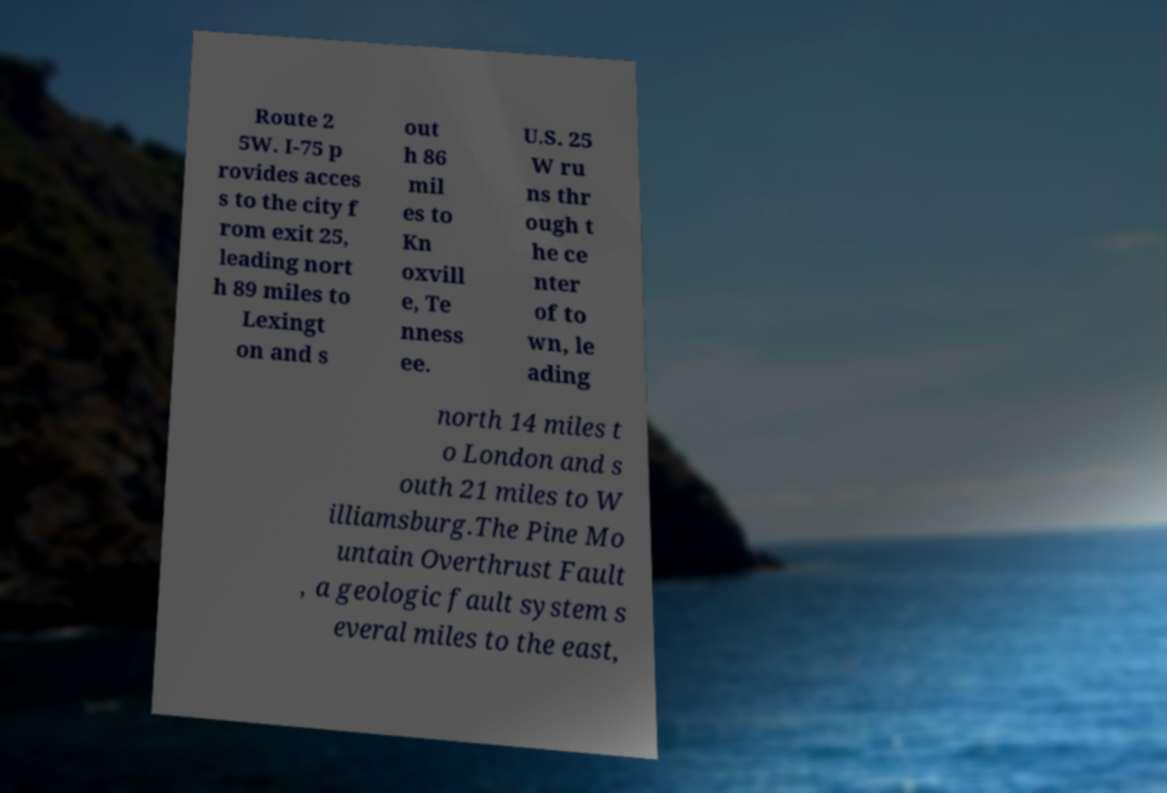Please read and relay the text visible in this image. What does it say? Route 2 5W. I-75 p rovides acces s to the city f rom exit 25, leading nort h 89 miles to Lexingt on and s out h 86 mil es to Kn oxvill e, Te nness ee. U.S. 25 W ru ns thr ough t he ce nter of to wn, le ading north 14 miles t o London and s outh 21 miles to W illiamsburg.The Pine Mo untain Overthrust Fault , a geologic fault system s everal miles to the east, 